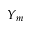Convert formula to latex. <formula><loc_0><loc_0><loc_500><loc_500>Y _ { m }</formula> 